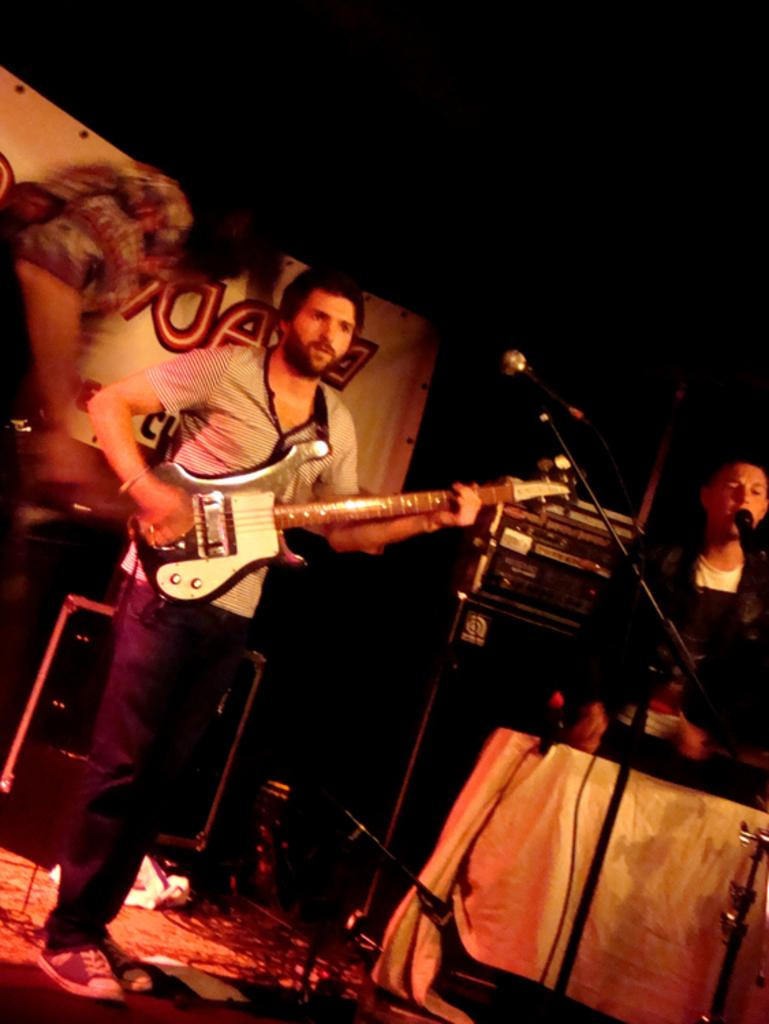What is the person in the image doing? The person is standing and playing a guitar while singing in front of a mic. What is the person using to amplify their voice? The person is using a mic with a mic holder. What other items can be seen in the image? There are electronic devices present in the image. What color is the banner in the image? The banner in the image is white. Is the person in the image at a hospital? There is no indication in the image that the person is at a hospital. 